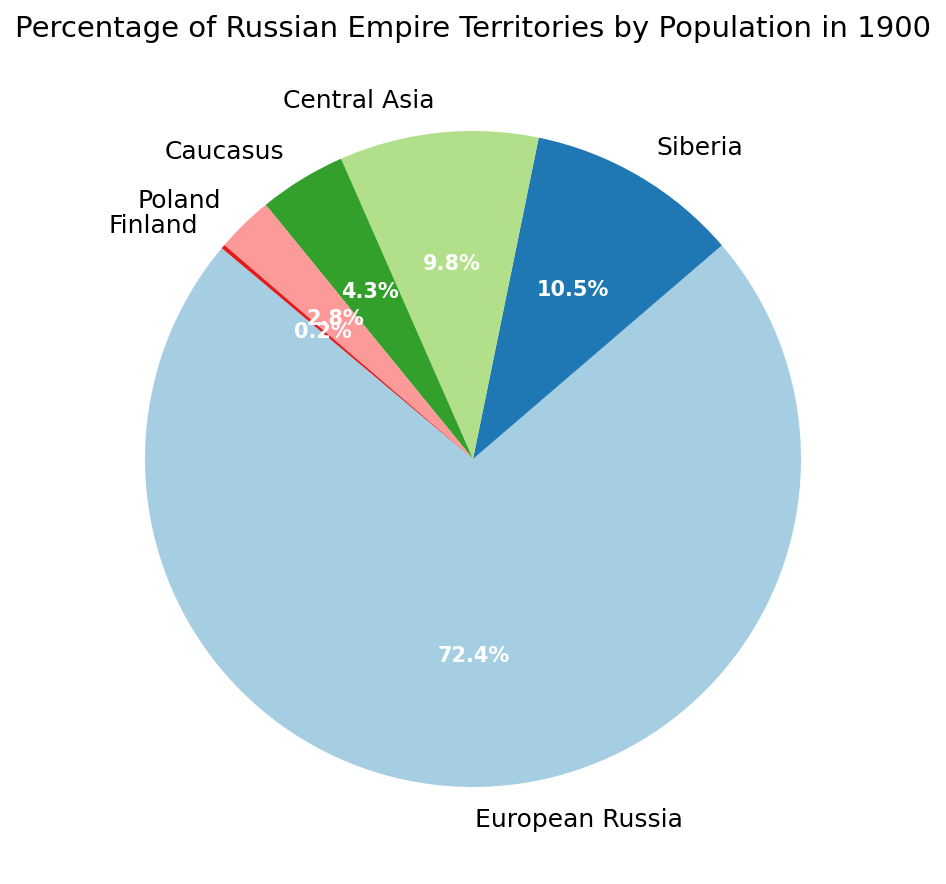Which territory has the highest percentage of the population in the Russian Empire in 1900? By looking at the pie chart, European Russia has the largest segment. Checking the labels, it shows a value of 72.4%.
Answer: European Russia What is the combined percentage population of Siberia and Central Asia in 1900? Adding the percentages given in the pie chart: 10.5% for Siberia and 9.8% for Central Asia. 10.5 + 9.8 = 20.3.
Answer: 20.3% How much larger is the population percentage of European Russia compared to Poland? Subtract the percentage of Poland from European Russia's percentage. 72.4% - 2.8% = 69.6%.
Answer: 69.6% Which territories combined make up less than 10% of the population? By observing the pie chart, the territories with less than 10% each are Caucasus (4.3%), Poland (2.8%), and Finland (0.2%). Summing them up, 4.3 + 2.8 + 0.2 = 7.3, which is less than 10%.
Answer: Caucasus, Poland, and Finland Which territory has the smallest percentage of the population in the Russian Empire in 1900? The pie chart shows that Finland has the smallest segment with a label indicating 0.2%.
Answer: Finland By how much does the percentage population of European Russia exceed the combined percentage of the Caucasus and Poland? Sum the percentages of Caucasus and Poland: 4.3% + 2.8% = 7.1%. Then subtract this from the percentage of European Russia: 72.4% - 7.1% = 65.3%.
Answer: 65.3% Which two territories have the closest population percentages and what are those percentages? By scanning the pie chart labels, Central Asia has 9.8% and Siberia has 10.5%. The difference is 10.5 - 9.8 = 0.7%, which is the smallest among the differences.
Answer: Central Asia (9.8%) and Siberia (10.5%) If you combine the populations of the Caucasus, Poland, and Finland, does their combined population percentage surpass that of Central Asia? Sum the percentages of the Caucasus, Poland, and Finland: 4.3% + 2.8% + 0.2% = 7.3%. Central Asia is 9.8%, and 7.3% is less than 9.8%, so it does not surpass.
Answer: No 